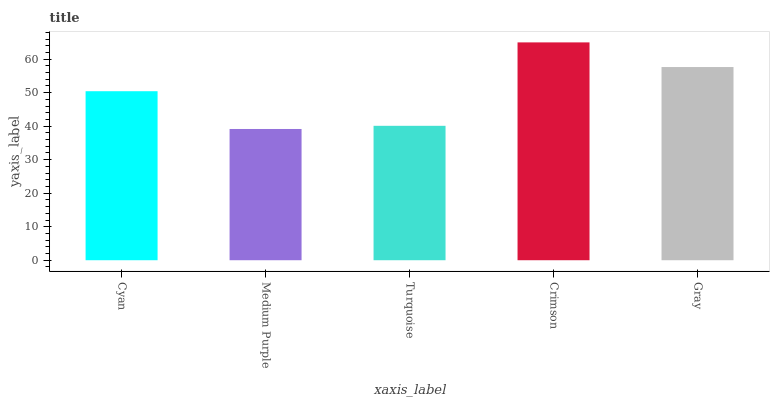Is Medium Purple the minimum?
Answer yes or no. Yes. Is Crimson the maximum?
Answer yes or no. Yes. Is Turquoise the minimum?
Answer yes or no. No. Is Turquoise the maximum?
Answer yes or no. No. Is Turquoise greater than Medium Purple?
Answer yes or no. Yes. Is Medium Purple less than Turquoise?
Answer yes or no. Yes. Is Medium Purple greater than Turquoise?
Answer yes or no. No. Is Turquoise less than Medium Purple?
Answer yes or no. No. Is Cyan the high median?
Answer yes or no. Yes. Is Cyan the low median?
Answer yes or no. Yes. Is Turquoise the high median?
Answer yes or no. No. Is Gray the low median?
Answer yes or no. No. 